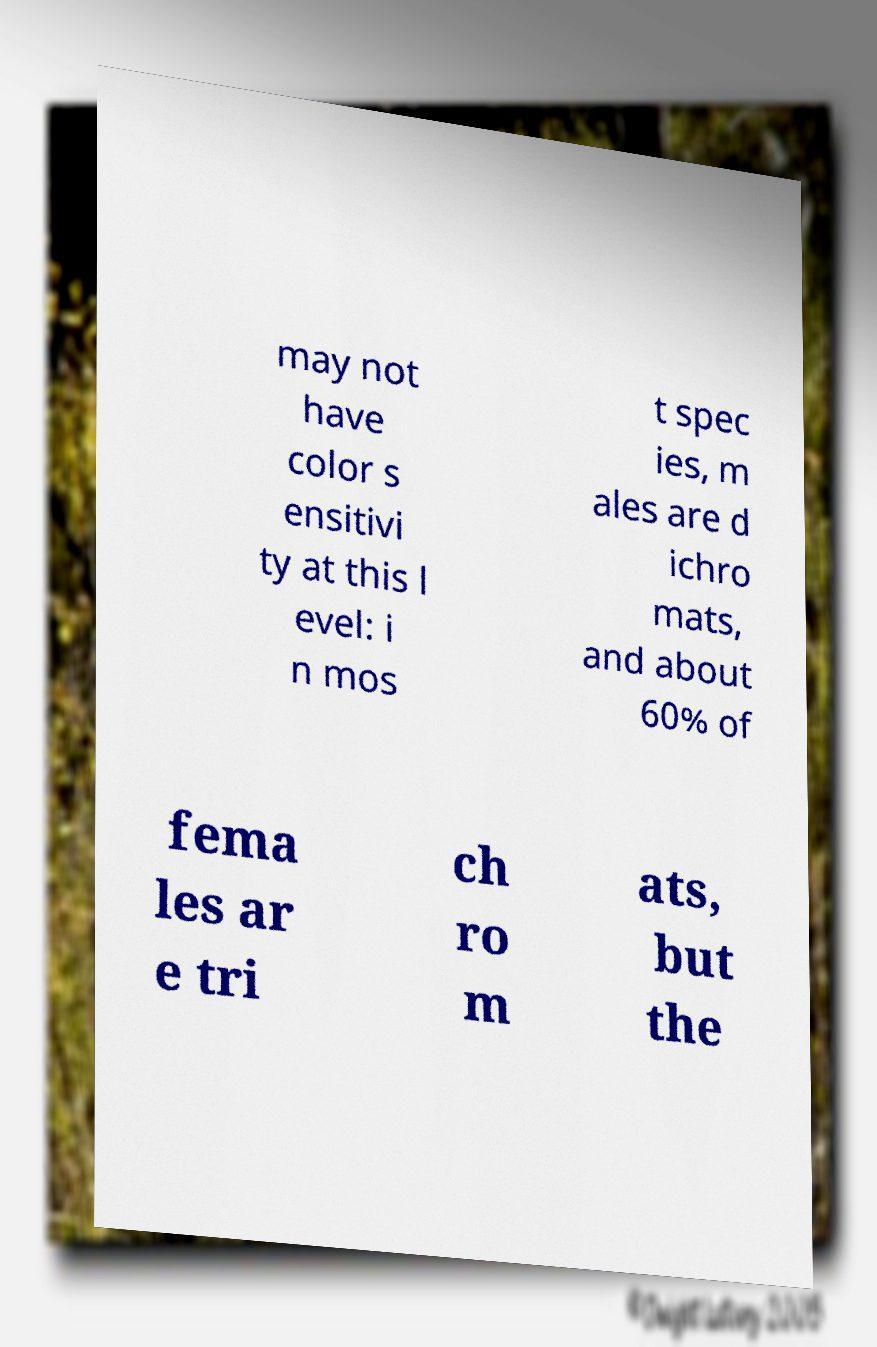Can you accurately transcribe the text from the provided image for me? may not have color s ensitivi ty at this l evel: i n mos t spec ies, m ales are d ichro mats, and about 60% of fema les ar e tri ch ro m ats, but the 